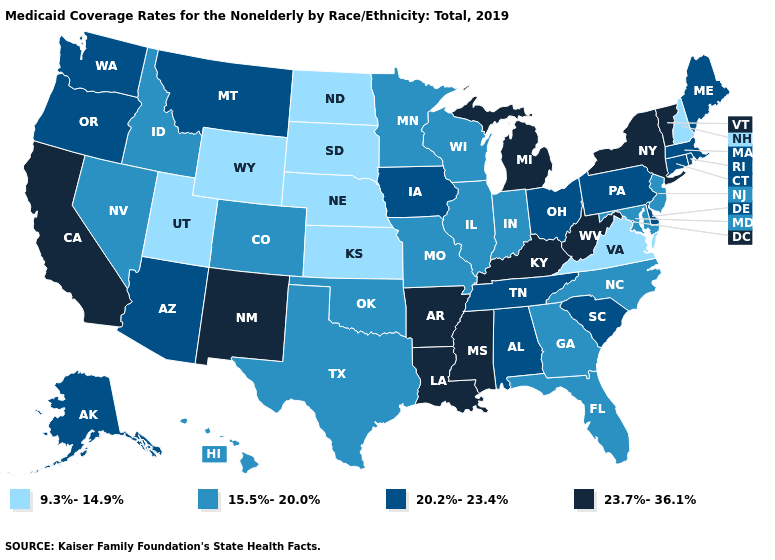Name the states that have a value in the range 15.5%-20.0%?
Keep it brief. Colorado, Florida, Georgia, Hawaii, Idaho, Illinois, Indiana, Maryland, Minnesota, Missouri, Nevada, New Jersey, North Carolina, Oklahoma, Texas, Wisconsin. What is the value of West Virginia?
Be succinct. 23.7%-36.1%. What is the value of Vermont?
Concise answer only. 23.7%-36.1%. What is the lowest value in the USA?
Give a very brief answer. 9.3%-14.9%. What is the value of Missouri?
Concise answer only. 15.5%-20.0%. What is the value of Georgia?
Quick response, please. 15.5%-20.0%. What is the value of Florida?
Write a very short answer. 15.5%-20.0%. Does Michigan have the highest value in the USA?
Give a very brief answer. Yes. What is the highest value in the USA?
Give a very brief answer. 23.7%-36.1%. Among the states that border North Dakota , does South Dakota have the highest value?
Concise answer only. No. Does Montana have the same value as Illinois?
Answer briefly. No. Does Nevada have a lower value than North Carolina?
Quick response, please. No. Among the states that border Virginia , does Maryland have the highest value?
Be succinct. No. Name the states that have a value in the range 20.2%-23.4%?
Concise answer only. Alabama, Alaska, Arizona, Connecticut, Delaware, Iowa, Maine, Massachusetts, Montana, Ohio, Oregon, Pennsylvania, Rhode Island, South Carolina, Tennessee, Washington. 